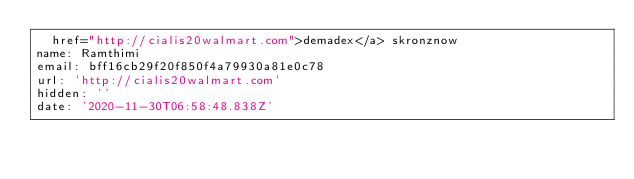<code> <loc_0><loc_0><loc_500><loc_500><_YAML_>  href="http://cialis20walmart.com">demadex</a> skronznow
name: Ramthimi
email: bff16cb29f20f850f4a79930a81e0c78
url: 'http://cialis20walmart.com'
hidden: ''
date: '2020-11-30T06:58:48.838Z'
</code> 